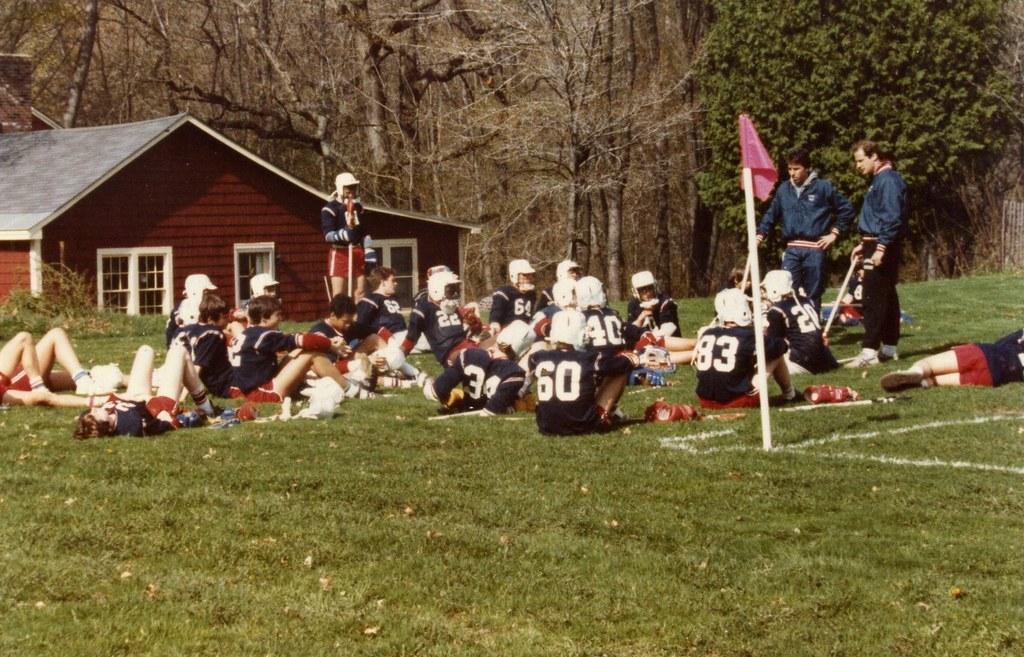Could you give a brief overview of what you see in this image? Here we can see group of people. Few of them are sitting on the ground and there are few persons lying on the ground. Here we can see a pole, flag, and a house. There are three persons standing on the ground. In the background we can see trees. 